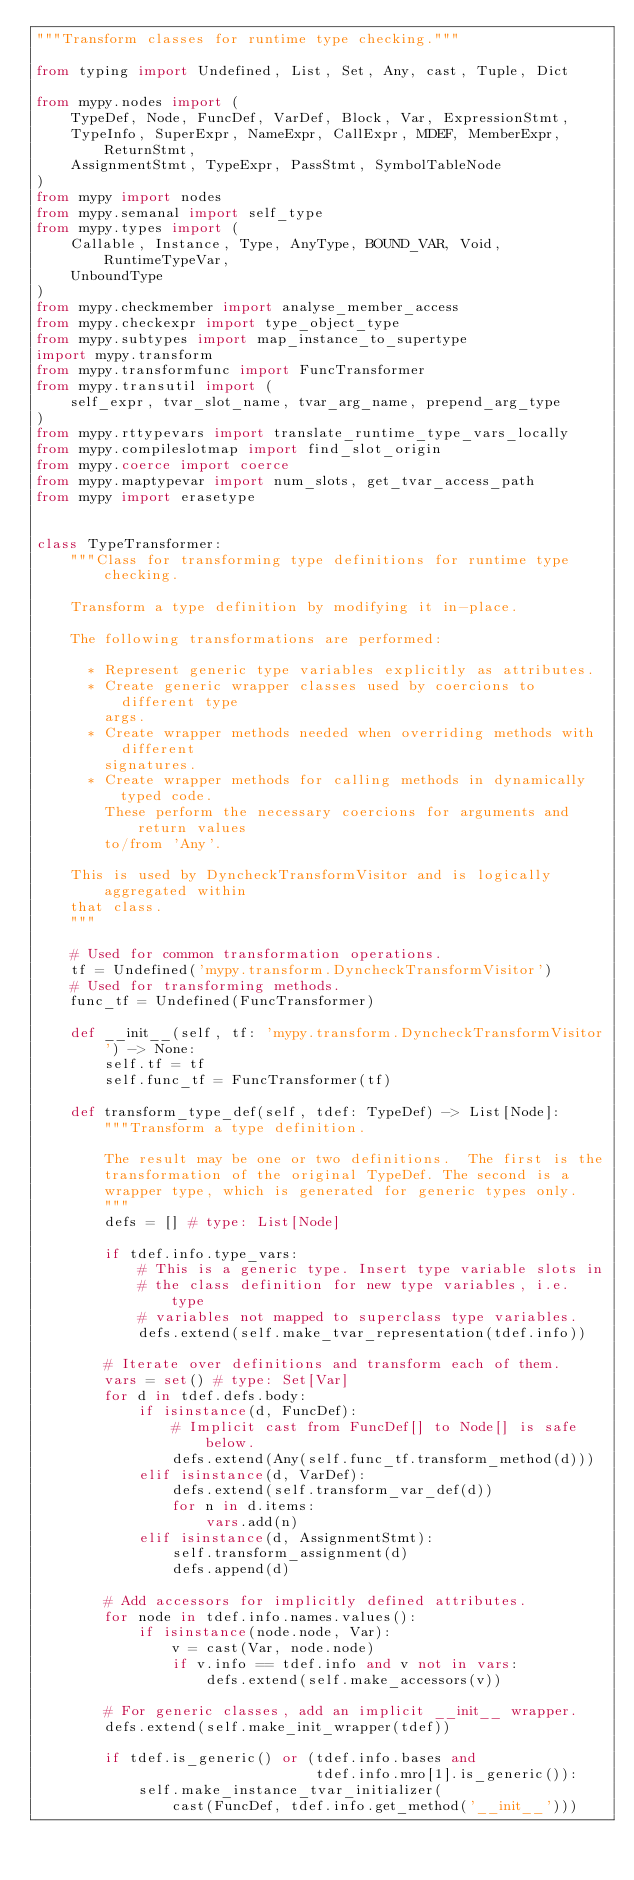Convert code to text. <code><loc_0><loc_0><loc_500><loc_500><_Python_>"""Transform classes for runtime type checking."""

from typing import Undefined, List, Set, Any, cast, Tuple, Dict

from mypy.nodes import (
    TypeDef, Node, FuncDef, VarDef, Block, Var, ExpressionStmt,
    TypeInfo, SuperExpr, NameExpr, CallExpr, MDEF, MemberExpr, ReturnStmt,
    AssignmentStmt, TypeExpr, PassStmt, SymbolTableNode
)
from mypy import nodes
from mypy.semanal import self_type
from mypy.types import (
    Callable, Instance, Type, AnyType, BOUND_VAR, Void, RuntimeTypeVar,
    UnboundType
)
from mypy.checkmember import analyse_member_access
from mypy.checkexpr import type_object_type
from mypy.subtypes import map_instance_to_supertype
import mypy.transform
from mypy.transformfunc import FuncTransformer
from mypy.transutil import (
    self_expr, tvar_slot_name, tvar_arg_name, prepend_arg_type
)
from mypy.rttypevars import translate_runtime_type_vars_locally
from mypy.compileslotmap import find_slot_origin
from mypy.coerce import coerce
from mypy.maptypevar import num_slots, get_tvar_access_path
from mypy import erasetype


class TypeTransformer:
    """Class for transforming type definitions for runtime type checking.

    Transform a type definition by modifying it in-place.

    The following transformations are performed:

      * Represent generic type variables explicitly as attributes.
      * Create generic wrapper classes used by coercions to different type
        args.
      * Create wrapper methods needed when overriding methods with different
        signatures.
      * Create wrapper methods for calling methods in dynamically typed code.
        These perform the necessary coercions for arguments and return values
        to/from 'Any'.
    
    This is used by DyncheckTransformVisitor and is logically aggregated within
    that class.
    """
    
    # Used for common transformation operations.
    tf = Undefined('mypy.transform.DyncheckTransformVisitor')
    # Used for transforming methods.
    func_tf = Undefined(FuncTransformer)
    
    def __init__(self, tf: 'mypy.transform.DyncheckTransformVisitor') -> None:
        self.tf = tf
        self.func_tf = FuncTransformer(tf)
    
    def transform_type_def(self, tdef: TypeDef) -> List[Node]:        
        """Transform a type definition.

        The result may be one or two definitions.  The first is the
        transformation of the original TypeDef. The second is a
        wrapper type, which is generated for generic types only.
        """
        defs = [] # type: List[Node]
        
        if tdef.info.type_vars:
            # This is a generic type. Insert type variable slots in
            # the class definition for new type variables, i.e. type
            # variables not mapped to superclass type variables.
            defs.extend(self.make_tvar_representation(tdef.info))
        
        # Iterate over definitions and transform each of them.
        vars = set() # type: Set[Var]
        for d in tdef.defs.body:
            if isinstance(d, FuncDef):
                # Implicit cast from FuncDef[] to Node[] is safe below.
                defs.extend(Any(self.func_tf.transform_method(d)))
            elif isinstance(d, VarDef):
                defs.extend(self.transform_var_def(d))
                for n in d.items:
                    vars.add(n)
            elif isinstance(d, AssignmentStmt):
                self.transform_assignment(d)
                defs.append(d)

        # Add accessors for implicitly defined attributes.
        for node in tdef.info.names.values():
            if isinstance(node.node, Var):
                v = cast(Var, node.node)
                if v.info == tdef.info and v not in vars:
                    defs.extend(self.make_accessors(v))
        
        # For generic classes, add an implicit __init__ wrapper.
        defs.extend(self.make_init_wrapper(tdef))
        
        if tdef.is_generic() or (tdef.info.bases and
                                 tdef.info.mro[1].is_generic()):
            self.make_instance_tvar_initializer(
                cast(FuncDef, tdef.info.get_method('__init__')))
</code> 